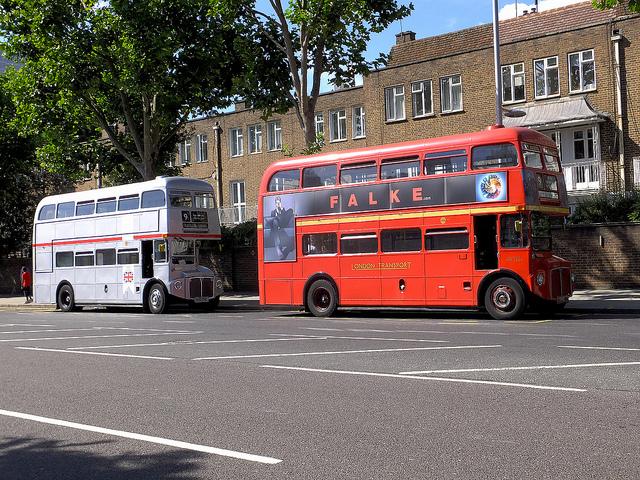Which bus is red?
Answer briefly. First 1. How many buses are there?
Answer briefly. 2. Are the buses on a street or parking lot?
Quick response, please. Parking lot. 